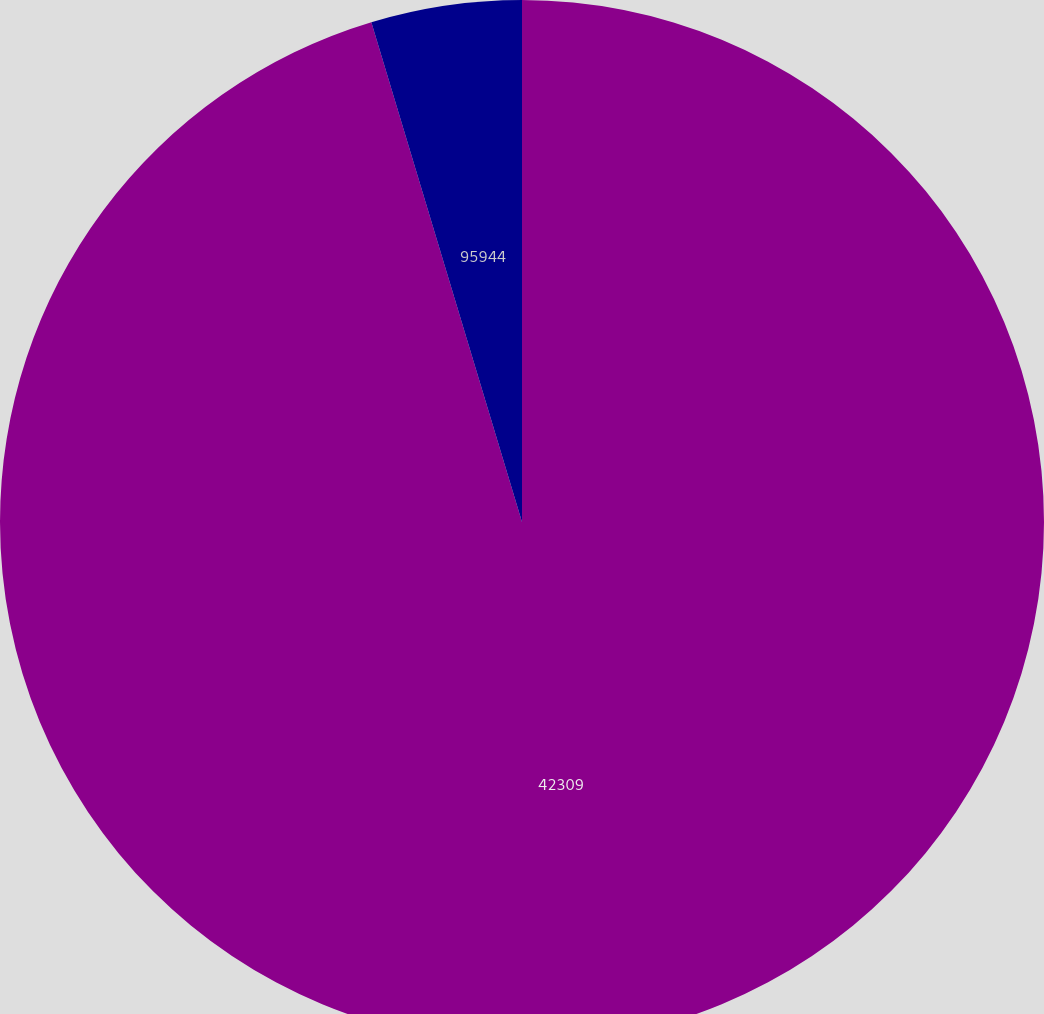<chart> <loc_0><loc_0><loc_500><loc_500><pie_chart><fcel>42309<fcel>95944<nl><fcel>95.34%<fcel>4.66%<nl></chart> 